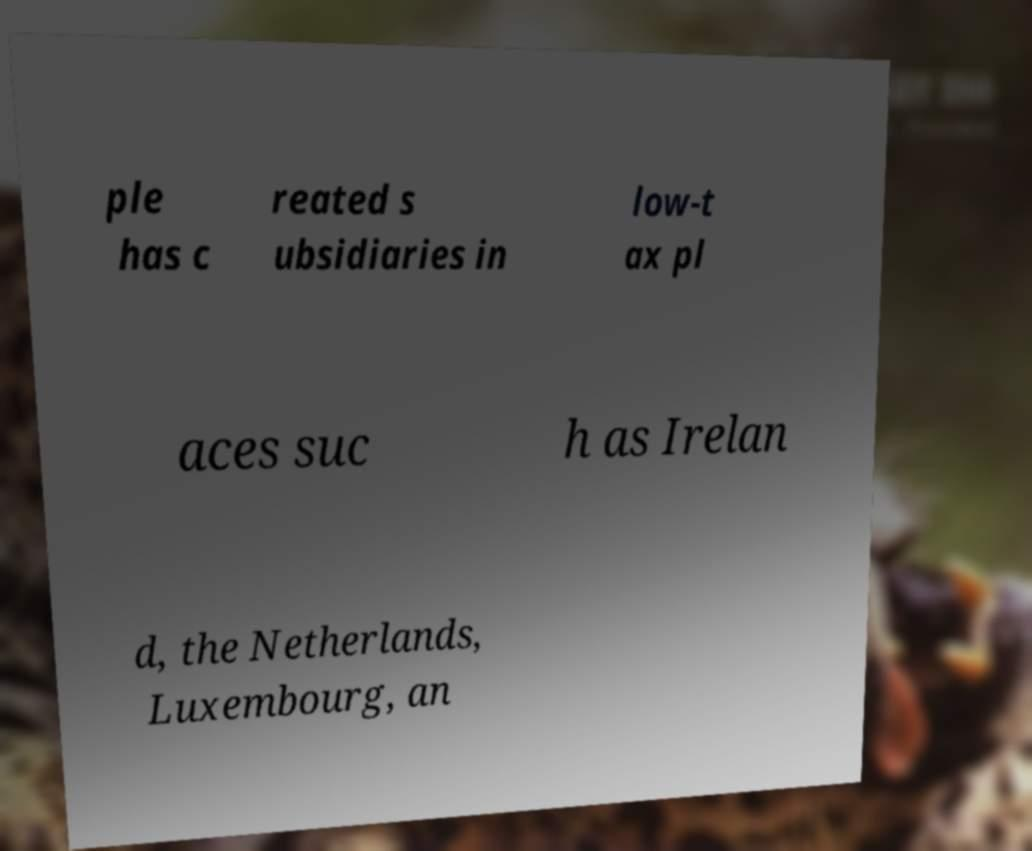Could you assist in decoding the text presented in this image and type it out clearly? ple has c reated s ubsidiaries in low-t ax pl aces suc h as Irelan d, the Netherlands, Luxembourg, an 